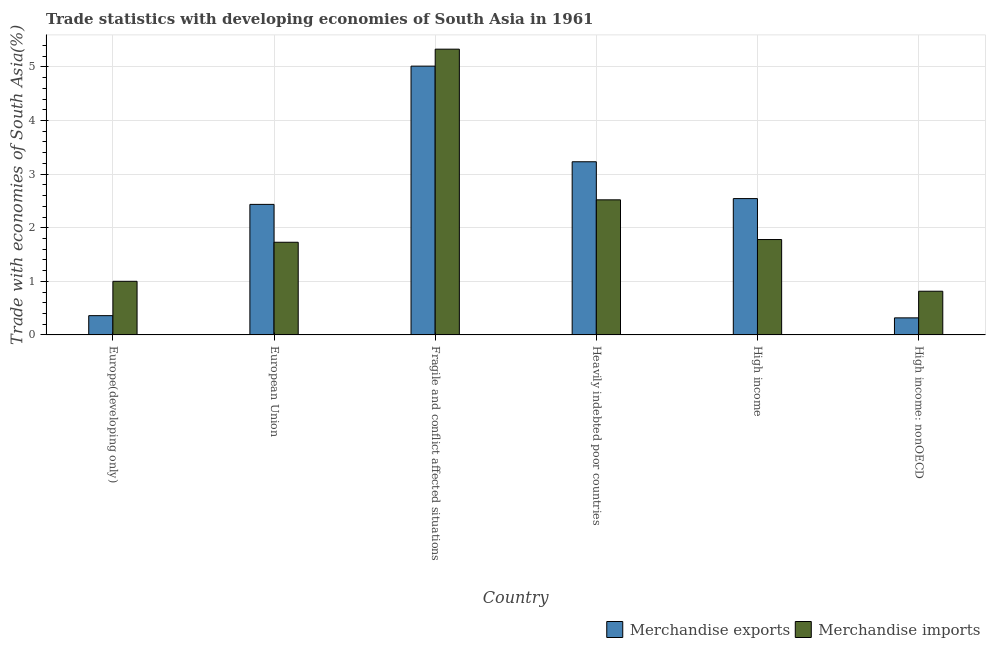How many different coloured bars are there?
Provide a succinct answer. 2. How many bars are there on the 4th tick from the left?
Provide a short and direct response. 2. What is the label of the 1st group of bars from the left?
Provide a short and direct response. Europe(developing only). What is the merchandise imports in High income: nonOECD?
Your answer should be compact. 0.82. Across all countries, what is the maximum merchandise exports?
Your answer should be compact. 5.02. Across all countries, what is the minimum merchandise imports?
Your answer should be very brief. 0.82. In which country was the merchandise exports maximum?
Offer a very short reply. Fragile and conflict affected situations. In which country was the merchandise imports minimum?
Offer a very short reply. High income: nonOECD. What is the total merchandise exports in the graph?
Provide a short and direct response. 13.9. What is the difference between the merchandise exports in European Union and that in Fragile and conflict affected situations?
Your answer should be very brief. -2.58. What is the difference between the merchandise exports in European Union and the merchandise imports in High income?
Offer a very short reply. 0.66. What is the average merchandise imports per country?
Your answer should be compact. 2.2. What is the difference between the merchandise imports and merchandise exports in High income?
Give a very brief answer. -0.76. In how many countries, is the merchandise exports greater than 1 %?
Your response must be concise. 4. What is the ratio of the merchandise exports in European Union to that in Heavily indebted poor countries?
Your answer should be very brief. 0.75. Is the merchandise exports in Fragile and conflict affected situations less than that in High income: nonOECD?
Your answer should be very brief. No. What is the difference between the highest and the second highest merchandise imports?
Your answer should be very brief. 2.81. What is the difference between the highest and the lowest merchandise exports?
Your answer should be very brief. 4.7. How many bars are there?
Your answer should be compact. 12. What is the difference between two consecutive major ticks on the Y-axis?
Give a very brief answer. 1. Are the values on the major ticks of Y-axis written in scientific E-notation?
Give a very brief answer. No. Does the graph contain any zero values?
Ensure brevity in your answer.  No. Does the graph contain grids?
Your response must be concise. Yes. Where does the legend appear in the graph?
Offer a very short reply. Bottom right. How are the legend labels stacked?
Your response must be concise. Horizontal. What is the title of the graph?
Give a very brief answer. Trade statistics with developing economies of South Asia in 1961. What is the label or title of the Y-axis?
Provide a short and direct response. Trade with economies of South Asia(%). What is the Trade with economies of South Asia(%) in Merchandise exports in Europe(developing only)?
Offer a very short reply. 0.36. What is the Trade with economies of South Asia(%) in Merchandise imports in Europe(developing only)?
Provide a short and direct response. 1. What is the Trade with economies of South Asia(%) of Merchandise exports in European Union?
Offer a terse response. 2.44. What is the Trade with economies of South Asia(%) in Merchandise imports in European Union?
Provide a succinct answer. 1.73. What is the Trade with economies of South Asia(%) of Merchandise exports in Fragile and conflict affected situations?
Give a very brief answer. 5.02. What is the Trade with economies of South Asia(%) in Merchandise imports in Fragile and conflict affected situations?
Make the answer very short. 5.33. What is the Trade with economies of South Asia(%) of Merchandise exports in Heavily indebted poor countries?
Your answer should be very brief. 3.23. What is the Trade with economies of South Asia(%) of Merchandise imports in Heavily indebted poor countries?
Your response must be concise. 2.52. What is the Trade with economies of South Asia(%) of Merchandise exports in High income?
Your response must be concise. 2.54. What is the Trade with economies of South Asia(%) in Merchandise imports in High income?
Provide a succinct answer. 1.78. What is the Trade with economies of South Asia(%) in Merchandise exports in High income: nonOECD?
Ensure brevity in your answer.  0.32. What is the Trade with economies of South Asia(%) in Merchandise imports in High income: nonOECD?
Keep it short and to the point. 0.82. Across all countries, what is the maximum Trade with economies of South Asia(%) of Merchandise exports?
Make the answer very short. 5.02. Across all countries, what is the maximum Trade with economies of South Asia(%) in Merchandise imports?
Ensure brevity in your answer.  5.33. Across all countries, what is the minimum Trade with economies of South Asia(%) of Merchandise exports?
Offer a very short reply. 0.32. Across all countries, what is the minimum Trade with economies of South Asia(%) in Merchandise imports?
Provide a short and direct response. 0.82. What is the total Trade with economies of South Asia(%) of Merchandise exports in the graph?
Your answer should be compact. 13.9. What is the total Trade with economies of South Asia(%) of Merchandise imports in the graph?
Provide a succinct answer. 13.18. What is the difference between the Trade with economies of South Asia(%) of Merchandise exports in Europe(developing only) and that in European Union?
Offer a very short reply. -2.08. What is the difference between the Trade with economies of South Asia(%) of Merchandise imports in Europe(developing only) and that in European Union?
Your answer should be compact. -0.73. What is the difference between the Trade with economies of South Asia(%) of Merchandise exports in Europe(developing only) and that in Fragile and conflict affected situations?
Offer a terse response. -4.66. What is the difference between the Trade with economies of South Asia(%) in Merchandise imports in Europe(developing only) and that in Fragile and conflict affected situations?
Offer a terse response. -4.33. What is the difference between the Trade with economies of South Asia(%) in Merchandise exports in Europe(developing only) and that in Heavily indebted poor countries?
Your response must be concise. -2.87. What is the difference between the Trade with economies of South Asia(%) in Merchandise imports in Europe(developing only) and that in Heavily indebted poor countries?
Your answer should be very brief. -1.52. What is the difference between the Trade with economies of South Asia(%) of Merchandise exports in Europe(developing only) and that in High income?
Make the answer very short. -2.18. What is the difference between the Trade with economies of South Asia(%) of Merchandise imports in Europe(developing only) and that in High income?
Offer a terse response. -0.78. What is the difference between the Trade with economies of South Asia(%) of Merchandise exports in Europe(developing only) and that in High income: nonOECD?
Provide a short and direct response. 0.04. What is the difference between the Trade with economies of South Asia(%) of Merchandise imports in Europe(developing only) and that in High income: nonOECD?
Ensure brevity in your answer.  0.19. What is the difference between the Trade with economies of South Asia(%) in Merchandise exports in European Union and that in Fragile and conflict affected situations?
Offer a terse response. -2.58. What is the difference between the Trade with economies of South Asia(%) in Merchandise imports in European Union and that in Fragile and conflict affected situations?
Offer a terse response. -3.6. What is the difference between the Trade with economies of South Asia(%) of Merchandise exports in European Union and that in Heavily indebted poor countries?
Offer a very short reply. -0.8. What is the difference between the Trade with economies of South Asia(%) of Merchandise imports in European Union and that in Heavily indebted poor countries?
Offer a terse response. -0.79. What is the difference between the Trade with economies of South Asia(%) of Merchandise exports in European Union and that in High income?
Your answer should be very brief. -0.11. What is the difference between the Trade with economies of South Asia(%) of Merchandise imports in European Union and that in High income?
Offer a terse response. -0.05. What is the difference between the Trade with economies of South Asia(%) in Merchandise exports in European Union and that in High income: nonOECD?
Provide a succinct answer. 2.12. What is the difference between the Trade with economies of South Asia(%) in Merchandise imports in European Union and that in High income: nonOECD?
Keep it short and to the point. 0.91. What is the difference between the Trade with economies of South Asia(%) in Merchandise exports in Fragile and conflict affected situations and that in Heavily indebted poor countries?
Provide a short and direct response. 1.78. What is the difference between the Trade with economies of South Asia(%) of Merchandise imports in Fragile and conflict affected situations and that in Heavily indebted poor countries?
Your response must be concise. 2.81. What is the difference between the Trade with economies of South Asia(%) in Merchandise exports in Fragile and conflict affected situations and that in High income?
Your response must be concise. 2.47. What is the difference between the Trade with economies of South Asia(%) in Merchandise imports in Fragile and conflict affected situations and that in High income?
Offer a very short reply. 3.55. What is the difference between the Trade with economies of South Asia(%) in Merchandise exports in Fragile and conflict affected situations and that in High income: nonOECD?
Offer a very short reply. 4.7. What is the difference between the Trade with economies of South Asia(%) in Merchandise imports in Fragile and conflict affected situations and that in High income: nonOECD?
Offer a terse response. 4.52. What is the difference between the Trade with economies of South Asia(%) of Merchandise exports in Heavily indebted poor countries and that in High income?
Make the answer very short. 0.69. What is the difference between the Trade with economies of South Asia(%) in Merchandise imports in Heavily indebted poor countries and that in High income?
Keep it short and to the point. 0.74. What is the difference between the Trade with economies of South Asia(%) in Merchandise exports in Heavily indebted poor countries and that in High income: nonOECD?
Your response must be concise. 2.91. What is the difference between the Trade with economies of South Asia(%) of Merchandise imports in Heavily indebted poor countries and that in High income: nonOECD?
Your response must be concise. 1.71. What is the difference between the Trade with economies of South Asia(%) in Merchandise exports in High income and that in High income: nonOECD?
Ensure brevity in your answer.  2.23. What is the difference between the Trade with economies of South Asia(%) in Merchandise imports in High income and that in High income: nonOECD?
Provide a short and direct response. 0.96. What is the difference between the Trade with economies of South Asia(%) of Merchandise exports in Europe(developing only) and the Trade with economies of South Asia(%) of Merchandise imports in European Union?
Offer a very short reply. -1.37. What is the difference between the Trade with economies of South Asia(%) of Merchandise exports in Europe(developing only) and the Trade with economies of South Asia(%) of Merchandise imports in Fragile and conflict affected situations?
Your answer should be very brief. -4.97. What is the difference between the Trade with economies of South Asia(%) of Merchandise exports in Europe(developing only) and the Trade with economies of South Asia(%) of Merchandise imports in Heavily indebted poor countries?
Offer a terse response. -2.16. What is the difference between the Trade with economies of South Asia(%) of Merchandise exports in Europe(developing only) and the Trade with economies of South Asia(%) of Merchandise imports in High income?
Your answer should be very brief. -1.42. What is the difference between the Trade with economies of South Asia(%) in Merchandise exports in Europe(developing only) and the Trade with economies of South Asia(%) in Merchandise imports in High income: nonOECD?
Keep it short and to the point. -0.46. What is the difference between the Trade with economies of South Asia(%) in Merchandise exports in European Union and the Trade with economies of South Asia(%) in Merchandise imports in Fragile and conflict affected situations?
Your answer should be very brief. -2.9. What is the difference between the Trade with economies of South Asia(%) in Merchandise exports in European Union and the Trade with economies of South Asia(%) in Merchandise imports in Heavily indebted poor countries?
Give a very brief answer. -0.08. What is the difference between the Trade with economies of South Asia(%) of Merchandise exports in European Union and the Trade with economies of South Asia(%) of Merchandise imports in High income?
Make the answer very short. 0.66. What is the difference between the Trade with economies of South Asia(%) in Merchandise exports in European Union and the Trade with economies of South Asia(%) in Merchandise imports in High income: nonOECD?
Offer a terse response. 1.62. What is the difference between the Trade with economies of South Asia(%) in Merchandise exports in Fragile and conflict affected situations and the Trade with economies of South Asia(%) in Merchandise imports in Heavily indebted poor countries?
Your answer should be very brief. 2.49. What is the difference between the Trade with economies of South Asia(%) of Merchandise exports in Fragile and conflict affected situations and the Trade with economies of South Asia(%) of Merchandise imports in High income?
Provide a short and direct response. 3.24. What is the difference between the Trade with economies of South Asia(%) of Merchandise exports in Fragile and conflict affected situations and the Trade with economies of South Asia(%) of Merchandise imports in High income: nonOECD?
Keep it short and to the point. 4.2. What is the difference between the Trade with economies of South Asia(%) in Merchandise exports in Heavily indebted poor countries and the Trade with economies of South Asia(%) in Merchandise imports in High income?
Provide a short and direct response. 1.45. What is the difference between the Trade with economies of South Asia(%) of Merchandise exports in Heavily indebted poor countries and the Trade with economies of South Asia(%) of Merchandise imports in High income: nonOECD?
Provide a succinct answer. 2.42. What is the difference between the Trade with economies of South Asia(%) of Merchandise exports in High income and the Trade with economies of South Asia(%) of Merchandise imports in High income: nonOECD?
Provide a succinct answer. 1.73. What is the average Trade with economies of South Asia(%) of Merchandise exports per country?
Ensure brevity in your answer.  2.32. What is the average Trade with economies of South Asia(%) of Merchandise imports per country?
Offer a terse response. 2.2. What is the difference between the Trade with economies of South Asia(%) of Merchandise exports and Trade with economies of South Asia(%) of Merchandise imports in Europe(developing only)?
Ensure brevity in your answer.  -0.64. What is the difference between the Trade with economies of South Asia(%) in Merchandise exports and Trade with economies of South Asia(%) in Merchandise imports in European Union?
Offer a terse response. 0.71. What is the difference between the Trade with economies of South Asia(%) of Merchandise exports and Trade with economies of South Asia(%) of Merchandise imports in Fragile and conflict affected situations?
Make the answer very short. -0.32. What is the difference between the Trade with economies of South Asia(%) of Merchandise exports and Trade with economies of South Asia(%) of Merchandise imports in Heavily indebted poor countries?
Give a very brief answer. 0.71. What is the difference between the Trade with economies of South Asia(%) in Merchandise exports and Trade with economies of South Asia(%) in Merchandise imports in High income?
Your response must be concise. 0.76. What is the difference between the Trade with economies of South Asia(%) in Merchandise exports and Trade with economies of South Asia(%) in Merchandise imports in High income: nonOECD?
Offer a very short reply. -0.5. What is the ratio of the Trade with economies of South Asia(%) of Merchandise exports in Europe(developing only) to that in European Union?
Give a very brief answer. 0.15. What is the ratio of the Trade with economies of South Asia(%) of Merchandise imports in Europe(developing only) to that in European Union?
Your response must be concise. 0.58. What is the ratio of the Trade with economies of South Asia(%) in Merchandise exports in Europe(developing only) to that in Fragile and conflict affected situations?
Offer a terse response. 0.07. What is the ratio of the Trade with economies of South Asia(%) of Merchandise imports in Europe(developing only) to that in Fragile and conflict affected situations?
Offer a terse response. 0.19. What is the ratio of the Trade with economies of South Asia(%) in Merchandise exports in Europe(developing only) to that in Heavily indebted poor countries?
Ensure brevity in your answer.  0.11. What is the ratio of the Trade with economies of South Asia(%) of Merchandise imports in Europe(developing only) to that in Heavily indebted poor countries?
Give a very brief answer. 0.4. What is the ratio of the Trade with economies of South Asia(%) in Merchandise exports in Europe(developing only) to that in High income?
Make the answer very short. 0.14. What is the ratio of the Trade with economies of South Asia(%) in Merchandise imports in Europe(developing only) to that in High income?
Your answer should be very brief. 0.56. What is the ratio of the Trade with economies of South Asia(%) in Merchandise exports in Europe(developing only) to that in High income: nonOECD?
Your answer should be compact. 1.13. What is the ratio of the Trade with economies of South Asia(%) of Merchandise imports in Europe(developing only) to that in High income: nonOECD?
Ensure brevity in your answer.  1.23. What is the ratio of the Trade with economies of South Asia(%) of Merchandise exports in European Union to that in Fragile and conflict affected situations?
Your answer should be compact. 0.49. What is the ratio of the Trade with economies of South Asia(%) in Merchandise imports in European Union to that in Fragile and conflict affected situations?
Your answer should be very brief. 0.32. What is the ratio of the Trade with economies of South Asia(%) of Merchandise exports in European Union to that in Heavily indebted poor countries?
Keep it short and to the point. 0.75. What is the ratio of the Trade with economies of South Asia(%) of Merchandise imports in European Union to that in Heavily indebted poor countries?
Offer a terse response. 0.69. What is the ratio of the Trade with economies of South Asia(%) of Merchandise exports in European Union to that in High income?
Your answer should be compact. 0.96. What is the ratio of the Trade with economies of South Asia(%) of Merchandise imports in European Union to that in High income?
Ensure brevity in your answer.  0.97. What is the ratio of the Trade with economies of South Asia(%) in Merchandise exports in European Union to that in High income: nonOECD?
Make the answer very short. 7.66. What is the ratio of the Trade with economies of South Asia(%) of Merchandise imports in European Union to that in High income: nonOECD?
Offer a very short reply. 2.12. What is the ratio of the Trade with economies of South Asia(%) in Merchandise exports in Fragile and conflict affected situations to that in Heavily indebted poor countries?
Provide a succinct answer. 1.55. What is the ratio of the Trade with economies of South Asia(%) of Merchandise imports in Fragile and conflict affected situations to that in Heavily indebted poor countries?
Make the answer very short. 2.12. What is the ratio of the Trade with economies of South Asia(%) of Merchandise exports in Fragile and conflict affected situations to that in High income?
Your answer should be compact. 1.97. What is the ratio of the Trade with economies of South Asia(%) of Merchandise imports in Fragile and conflict affected situations to that in High income?
Provide a short and direct response. 3. What is the ratio of the Trade with economies of South Asia(%) of Merchandise exports in Fragile and conflict affected situations to that in High income: nonOECD?
Your answer should be very brief. 15.76. What is the ratio of the Trade with economies of South Asia(%) in Merchandise imports in Fragile and conflict affected situations to that in High income: nonOECD?
Keep it short and to the point. 6.54. What is the ratio of the Trade with economies of South Asia(%) of Merchandise exports in Heavily indebted poor countries to that in High income?
Ensure brevity in your answer.  1.27. What is the ratio of the Trade with economies of South Asia(%) of Merchandise imports in Heavily indebted poor countries to that in High income?
Make the answer very short. 1.42. What is the ratio of the Trade with economies of South Asia(%) in Merchandise exports in Heavily indebted poor countries to that in High income: nonOECD?
Give a very brief answer. 10.16. What is the ratio of the Trade with economies of South Asia(%) of Merchandise imports in Heavily indebted poor countries to that in High income: nonOECD?
Keep it short and to the point. 3.09. What is the ratio of the Trade with economies of South Asia(%) of Merchandise exports in High income to that in High income: nonOECD?
Make the answer very short. 8. What is the ratio of the Trade with economies of South Asia(%) of Merchandise imports in High income to that in High income: nonOECD?
Provide a succinct answer. 2.18. What is the difference between the highest and the second highest Trade with economies of South Asia(%) in Merchandise exports?
Make the answer very short. 1.78. What is the difference between the highest and the second highest Trade with economies of South Asia(%) in Merchandise imports?
Provide a succinct answer. 2.81. What is the difference between the highest and the lowest Trade with economies of South Asia(%) in Merchandise exports?
Your response must be concise. 4.7. What is the difference between the highest and the lowest Trade with economies of South Asia(%) of Merchandise imports?
Ensure brevity in your answer.  4.52. 